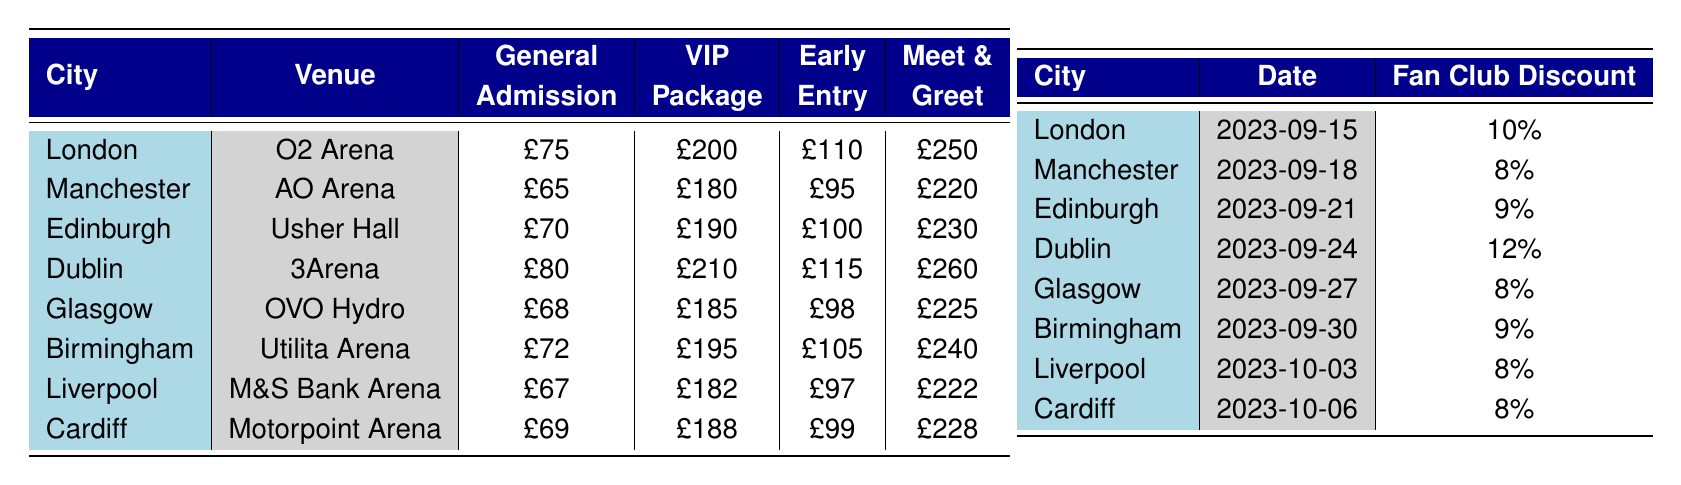What is the ticket price for the VIP Package in London? The table indicates that the ticket price for the VIP Package in London is listed as £200.
Answer: £200 Which city has the lowest General Admission price? Looking at the prices for General Admission, Liverpool has the lowest price at £67.
Answer: Liverpool What is the date of the concert in Birmingham? The concert date for Birmingham is provided in the table as September 30, 2023.
Answer: 2023-09-30 Which cities offer an Early Entry ticket type for under £100? The cities with Early Entry ticket prices below £100 are Liverpool (£97), Glasgow (£98), and Cardiff (£99).
Answer: Liverpool, Glasgow, Cardiff What is the total amount you would pay for a Meet & Greet ticket in Dublin and a VIP Package in Manchester? The Meet & Greet price in Dublin is £260, and the VIP Package price in Manchester is £180. Adding these together gives £260 + £180 = £440.
Answer: £440 Is there a fan club discount of at least 10% available for any city? Upon reviewing the fan club discounts, Dublin offers a 12% discount, which is greater than 10%, so the answer is yes.
Answer: Yes Calculate the average ticket price for General Admission across all cities. The prices for General Admission are £75 (London), £65 (Manchester), £70 (Edinburgh), £80 (Dublin), £68 (Glasgow), £72 (Birmingham), £67 (Liverpool), and £69 (Cardiff). The total sum is £75 + £65 + £70 + £80 + £68 + £72 + £67 + £69 = £596. The average is £596 / 8 = £74.5.
Answer: £74.5 Which city has the highest price for the Early Entry ticket? By comparing the Early Entry prices, Dublin (£115) has the highest price among all listed cities.
Answer: Dublin If a fan from Cardiff wants to buy a VIP Package ticket, what would be the final price after applying the discount? The VIP Package price in Cardiff is £188. With a fan club discount of 8%, the discount amount is £188 * 0.08 = £15.04. The final price is £188 - £15.04 = £172.96.
Answer: £172.96 Are ticket prices for Meet & Greet higher than £240 in every city? Comparing the Meet & Greet prices, only Birmingham (£240) and Glasgow (£225) are equal to or below £240, so the statement is false.
Answer: No 